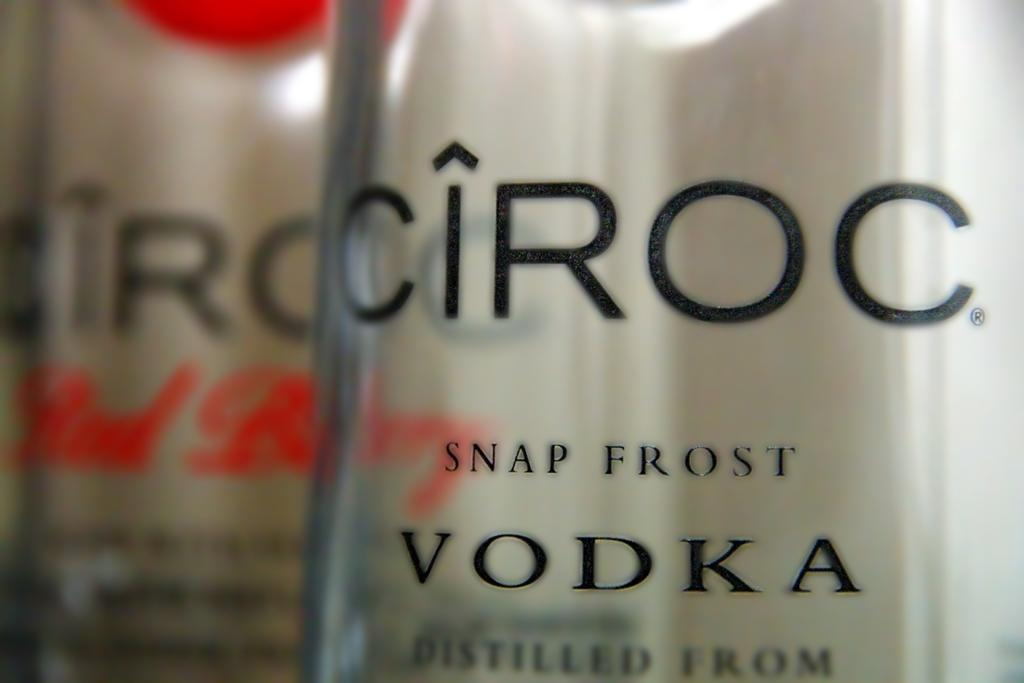<image>
Write a terse but informative summary of the picture. A close up of bottle of Ciroc Snap Frost Vodka. 